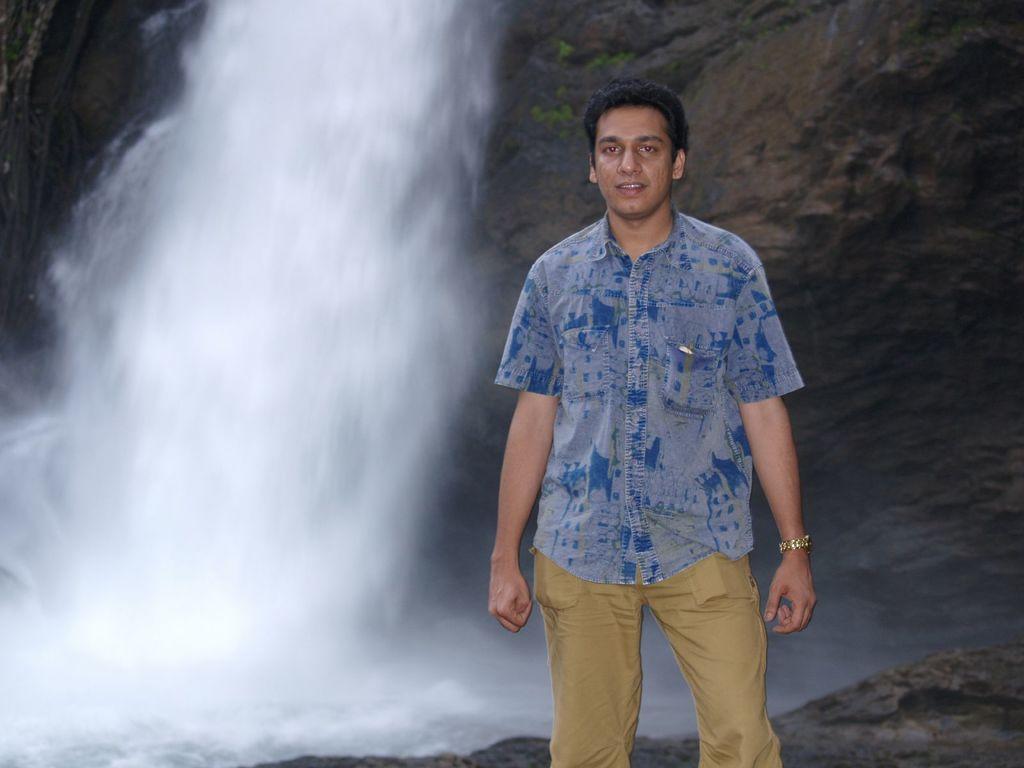How would you summarize this image in a sentence or two? In the image in the center we can see one man standing and he is smiling,which we can see on his face. In the background there is a hill and water. 